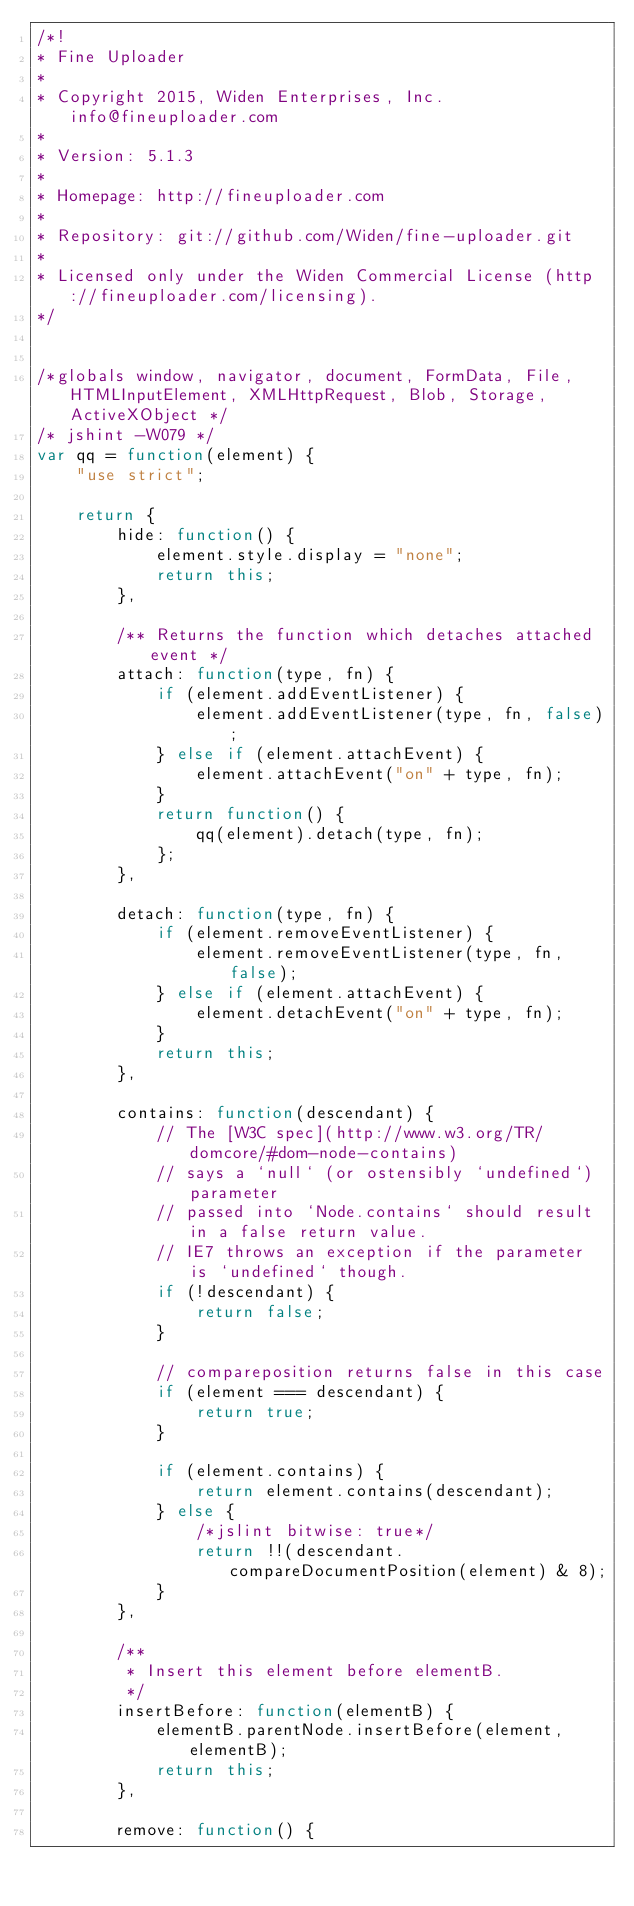<code> <loc_0><loc_0><loc_500><loc_500><_JavaScript_>/*!
* Fine Uploader
*
* Copyright 2015, Widen Enterprises, Inc. info@fineuploader.com
*
* Version: 5.1.3
*
* Homepage: http://fineuploader.com
*
* Repository: git://github.com/Widen/fine-uploader.git
*
* Licensed only under the Widen Commercial License (http://fineuploader.com/licensing).
*/ 


/*globals window, navigator, document, FormData, File, HTMLInputElement, XMLHttpRequest, Blob, Storage, ActiveXObject */
/* jshint -W079 */
var qq = function(element) {
    "use strict";

    return {
        hide: function() {
            element.style.display = "none";
            return this;
        },

        /** Returns the function which detaches attached event */
        attach: function(type, fn) {
            if (element.addEventListener) {
                element.addEventListener(type, fn, false);
            } else if (element.attachEvent) {
                element.attachEvent("on" + type, fn);
            }
            return function() {
                qq(element).detach(type, fn);
            };
        },

        detach: function(type, fn) {
            if (element.removeEventListener) {
                element.removeEventListener(type, fn, false);
            } else if (element.attachEvent) {
                element.detachEvent("on" + type, fn);
            }
            return this;
        },

        contains: function(descendant) {
            // The [W3C spec](http://www.w3.org/TR/domcore/#dom-node-contains)
            // says a `null` (or ostensibly `undefined`) parameter
            // passed into `Node.contains` should result in a false return value.
            // IE7 throws an exception if the parameter is `undefined` though.
            if (!descendant) {
                return false;
            }

            // compareposition returns false in this case
            if (element === descendant) {
                return true;
            }

            if (element.contains) {
                return element.contains(descendant);
            } else {
                /*jslint bitwise: true*/
                return !!(descendant.compareDocumentPosition(element) & 8);
            }
        },

        /**
         * Insert this element before elementB.
         */
        insertBefore: function(elementB) {
            elementB.parentNode.insertBefore(element, elementB);
            return this;
        },

        remove: function() {</code> 